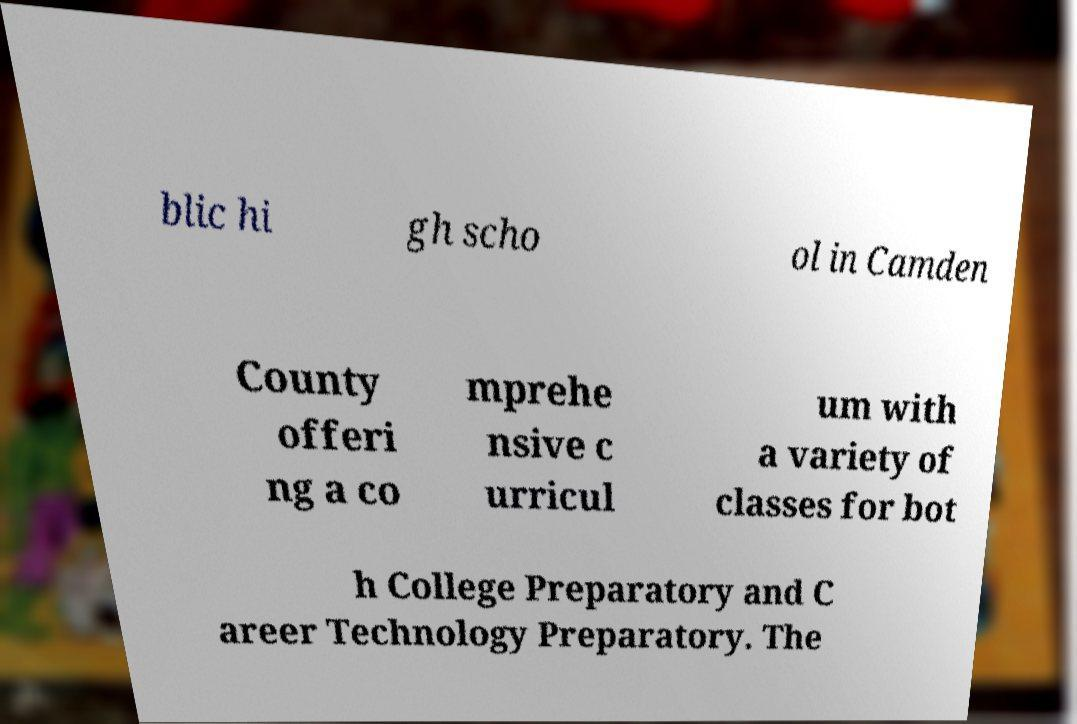There's text embedded in this image that I need extracted. Can you transcribe it verbatim? blic hi gh scho ol in Camden County offeri ng a co mprehe nsive c urricul um with a variety of classes for bot h College Preparatory and C areer Technology Preparatory. The 